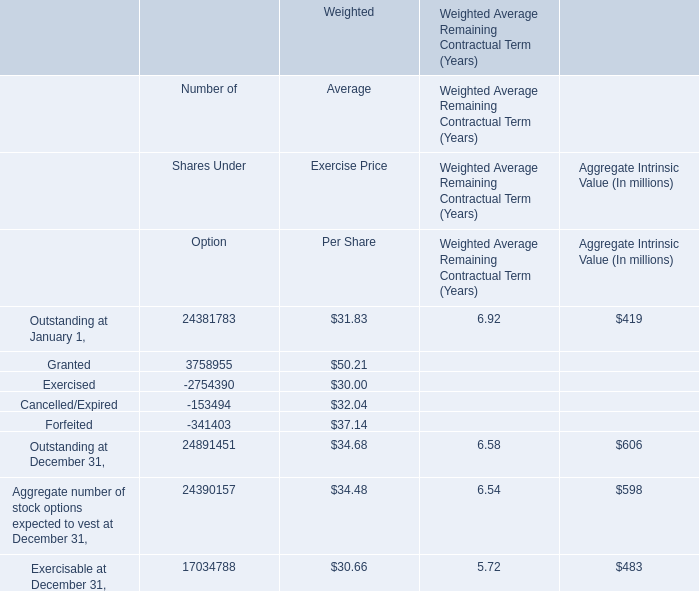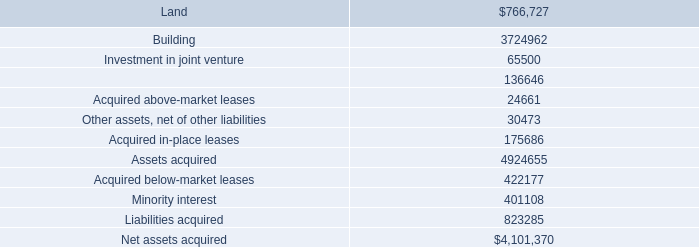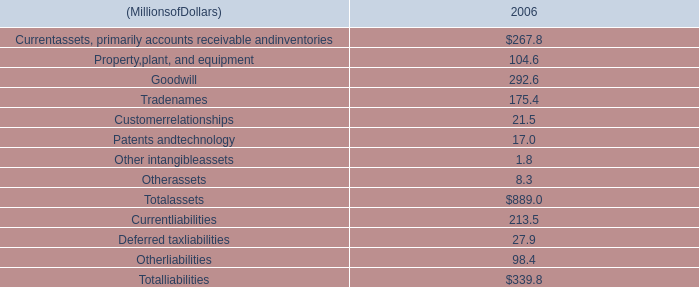What is the sum of Forfeited of Weighted Number of Shares Under Option, Investment in joint venture, and Building ? 
Computations: ((341403.0 + 65500.0) + 3724962.0)
Answer: 4131865.0. 